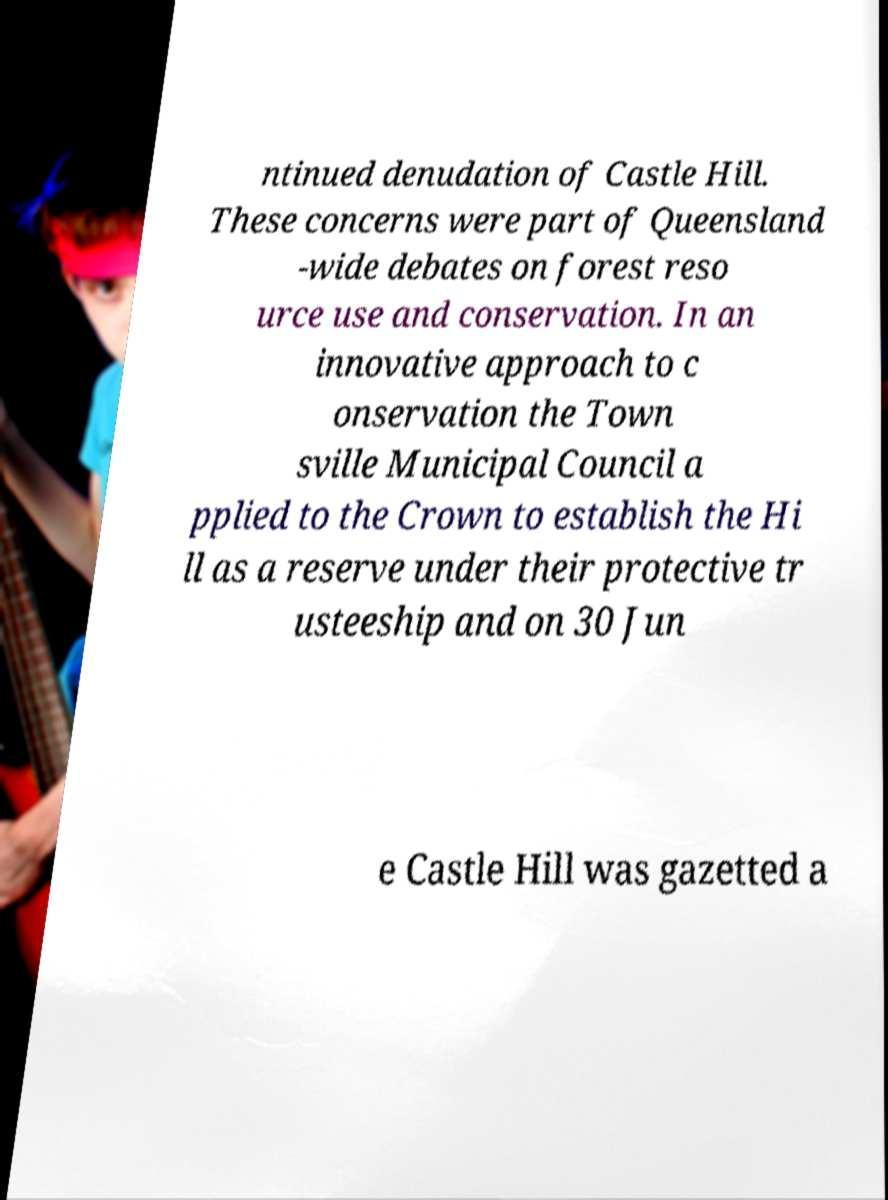Please read and relay the text visible in this image. What does it say? ntinued denudation of Castle Hill. These concerns were part of Queensland -wide debates on forest reso urce use and conservation. In an innovative approach to c onservation the Town sville Municipal Council a pplied to the Crown to establish the Hi ll as a reserve under their protective tr usteeship and on 30 Jun e Castle Hill was gazetted a 